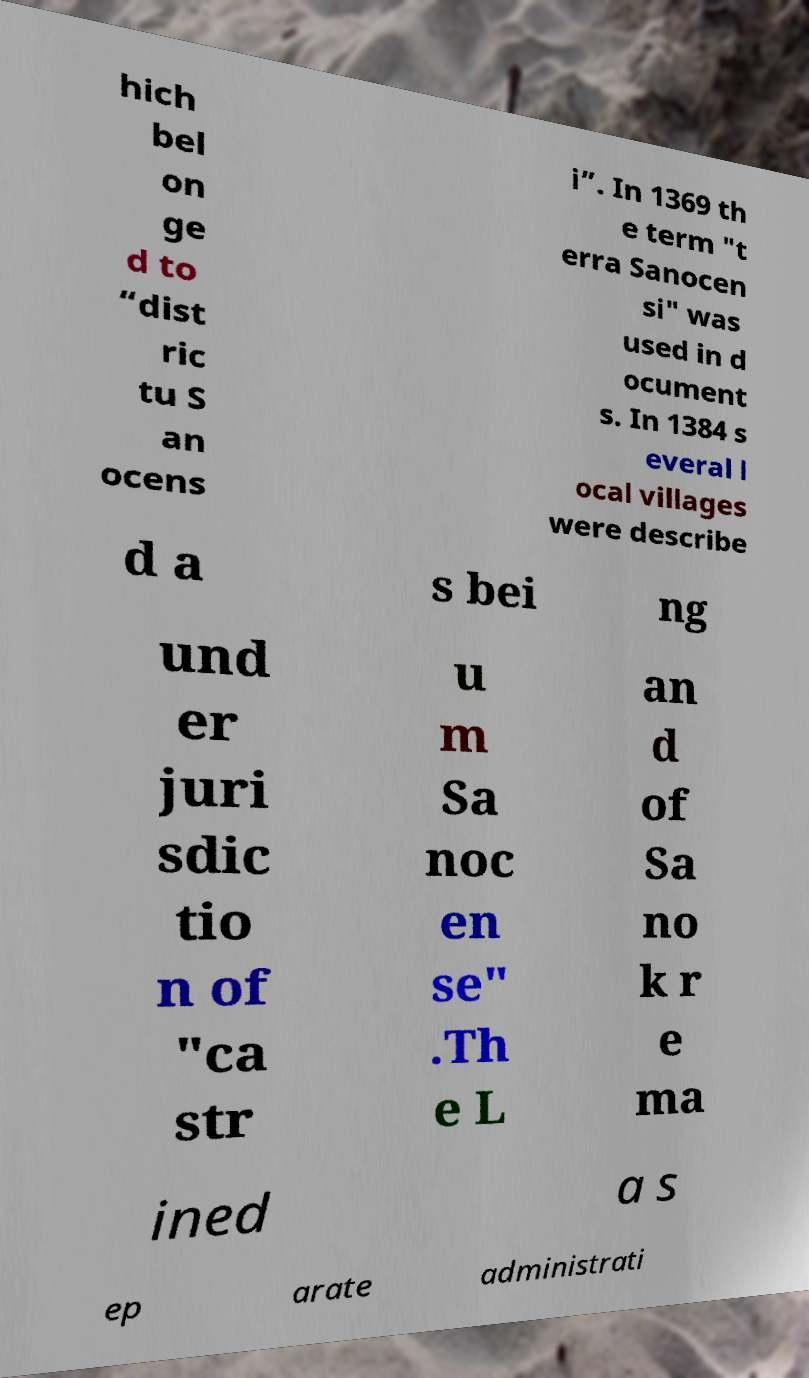What messages or text are displayed in this image? I need them in a readable, typed format. hich bel on ge d to “dist ric tu S an ocens i”. In 1369 th e term "t erra Sanocen si" was used in d ocument s. In 1384 s everal l ocal villages were describe d a s bei ng und er juri sdic tio n of "ca str u m Sa noc en se" .Th e L an d of Sa no k r e ma ined a s ep arate administrati 